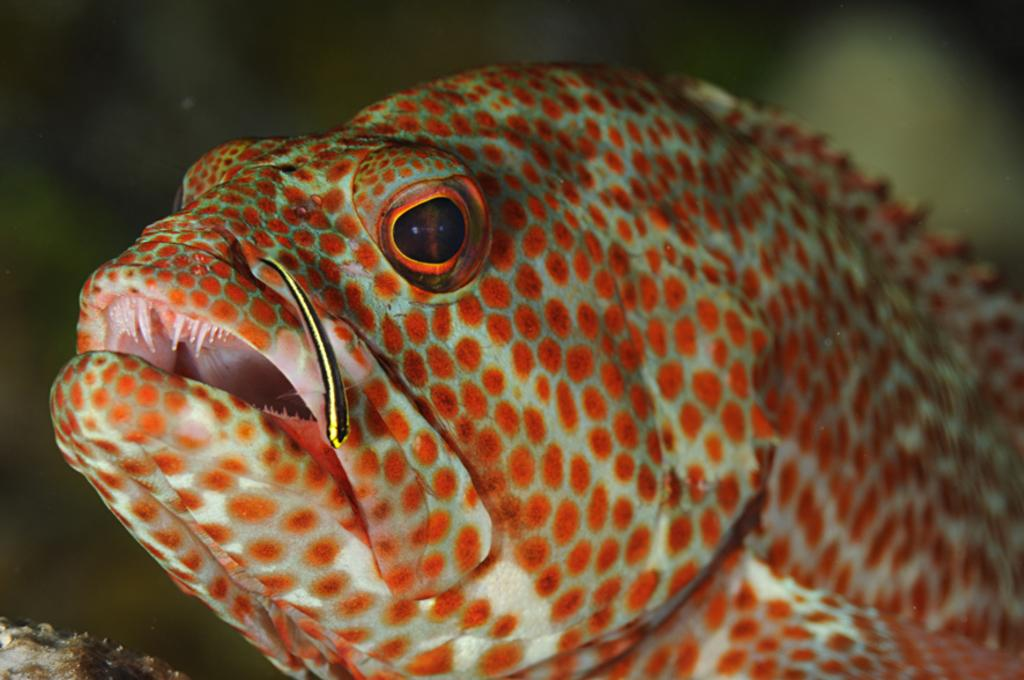What type of creature is present in the image? There is an animal in the image. Can you describe the background of the image? The background of the image is blurred. How many kittens are playing with the bubble in the image? There are no kittens or bubbles present in the image. 